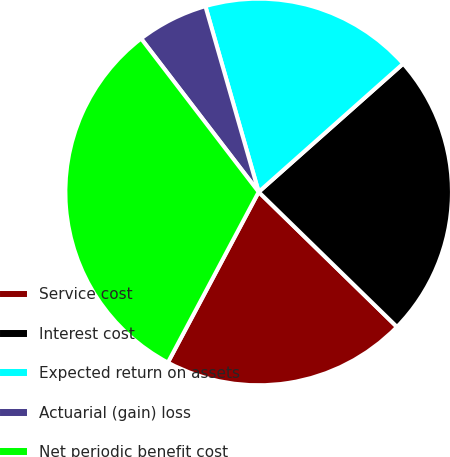Convert chart to OTSL. <chart><loc_0><loc_0><loc_500><loc_500><pie_chart><fcel>Service cost<fcel>Interest cost<fcel>Expected return on assets<fcel>Actuarial (gain) loss<fcel>Net periodic benefit cost<nl><fcel>20.48%<fcel>23.86%<fcel>17.89%<fcel>5.96%<fcel>31.81%<nl></chart> 